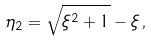Convert formula to latex. <formula><loc_0><loc_0><loc_500><loc_500>\eta _ { 2 } = \sqrt { \xi ^ { 2 } + 1 } - \xi \, ,</formula> 